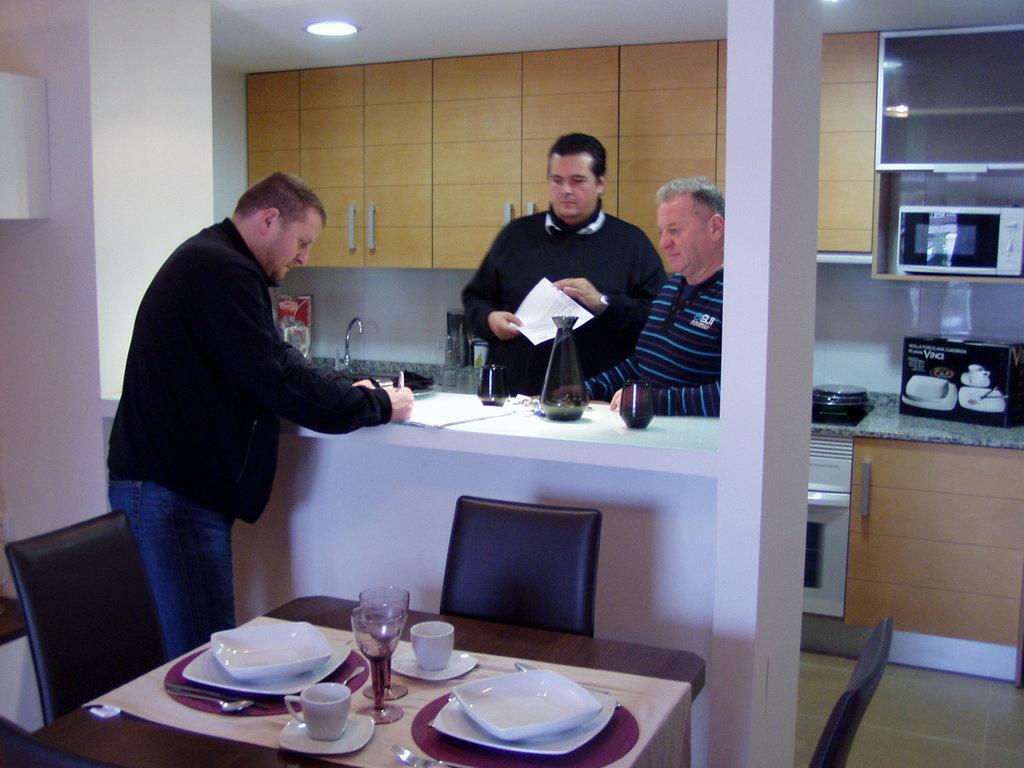In one or two sentences, can you explain what this image depicts? In this image, There is a black color table, There are some white color plates and there are some cups which are in white color, There are some glasses on the table, There are some people standing, In the background there are some yellow color cupboards and there is a white color wall in the left side of the image. 